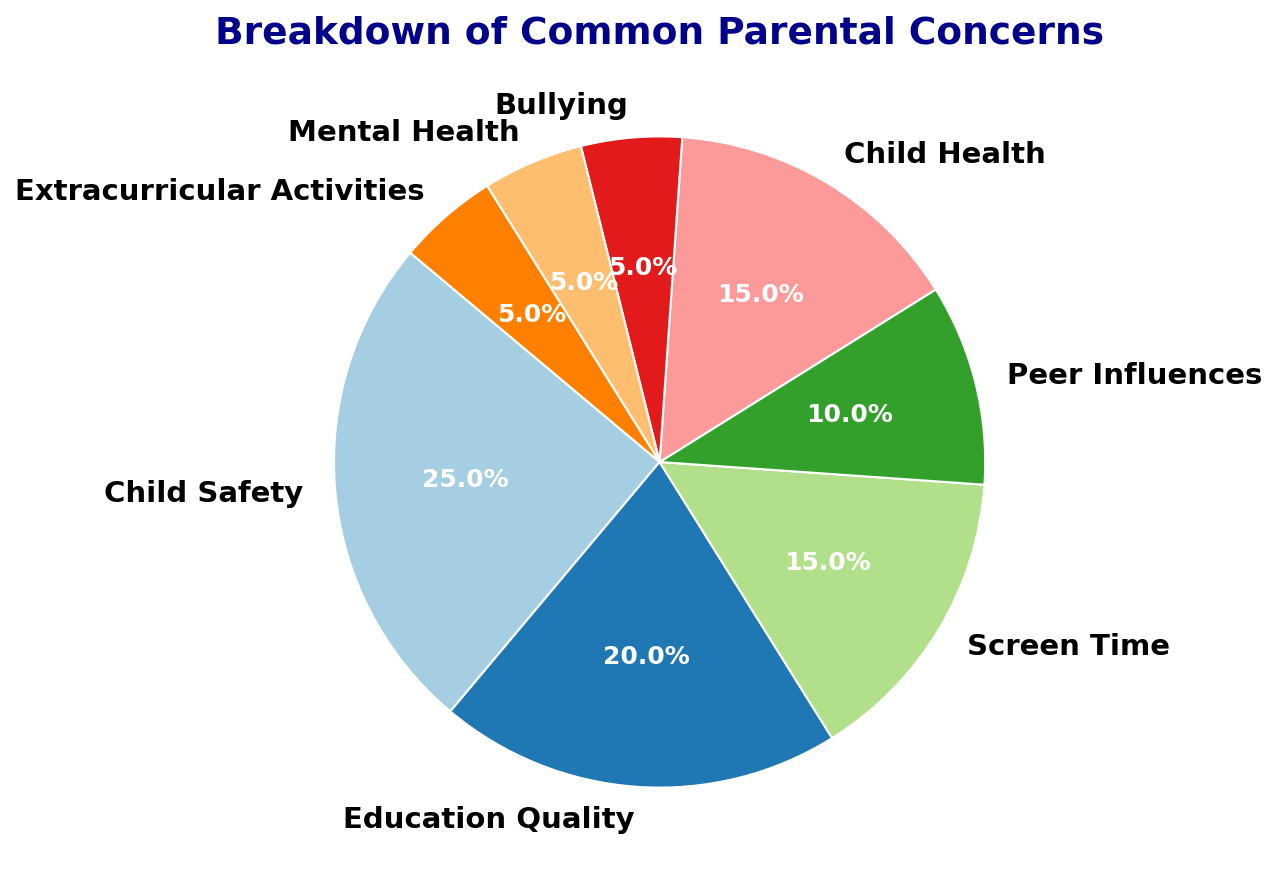What is the most common parental concern? The most common concern is the one with the highest percentage in the pie chart. By looking at the chart, "Child Safety" has the largest slice, corresponding to 25%.
Answer: Child Safety Which concerns are tied for the least common according to the chart? The least common concerns are those with the smallest percentages. From the chart, both "Bullying," "Mental Health," and "Extracurricular Activities" are tied with 5% each.
Answer: Bullying, Mental Health, Extracurricular Activities How much larger is the percentage of concern for "Child Safety" compared to "Peer Influences"? To find this, subtract the percentage for "Peer Influences" from "Child Safety". That is, 25% - 10% = 15%.
Answer: 15% Which two concerns combined make up the same percentage as "Child Safety"? To find this, look for two sections whose combined percentages equal "Child Safety" (25%). "Education Quality" is 20% and "Bullying" is 5%, which together sum up to 25%.
Answer: Education Quality and Bullying What is the total percentage for concerns related to "Health" and "Mental Health"? Add the percentages for "Child Health" and "Mental Health". That is, 15% + 5% = 20%.
Answer: 20% How does the concern for "Screen Time" compare to the "Education Quality" percentage? Compare the two percentages directly: "Screen Time" is 15% and "Education Quality" is 20%. "Screen Time" is 5% less than "Education Quality".
Answer: 5% less What percentage of concerns are focused on social-related issues like "Peer Influences" and "Bullying"? Sum the percentages of "Peer Influences" and "Bullying". That is, 10% + 5% = 15%.
Answer: 15% Identify three concerns that together make up 45% of the total concerns. Look for three segments that sum up to 45%. "Screen Time" (15%), "Child Health" (15%), and "Peer Influences" (10%) together make 40%, adding "Mental Health" (5%) makes it 45%.
Answer: Screen Time, Child Health, Peer Influences, and Mental Health If "Mental Health" were to increase by 10%, what would the new total percentage of concerns be? Add the current percentage of "Mental Health" to the increase: 5% + 10% = 15%. Then calculate the new total by adding the increase to the original total of all concerns, which is 100% + 10% = 110%.
Answer: 110% Which concerns have percentages greater than the average percentage of all concerns? First, find the average by dividing the total percentage by the number of concerns: 100% / 8 = 12.5%. Then, identify concerns with percentages greater than 12.5%: "Child Safety" (25%), "Education Quality" (20%), "Screen Time" (15%), and "Child Health" (15%).
Answer: Child Safety, Education Quality, Screen Time, Child Health 